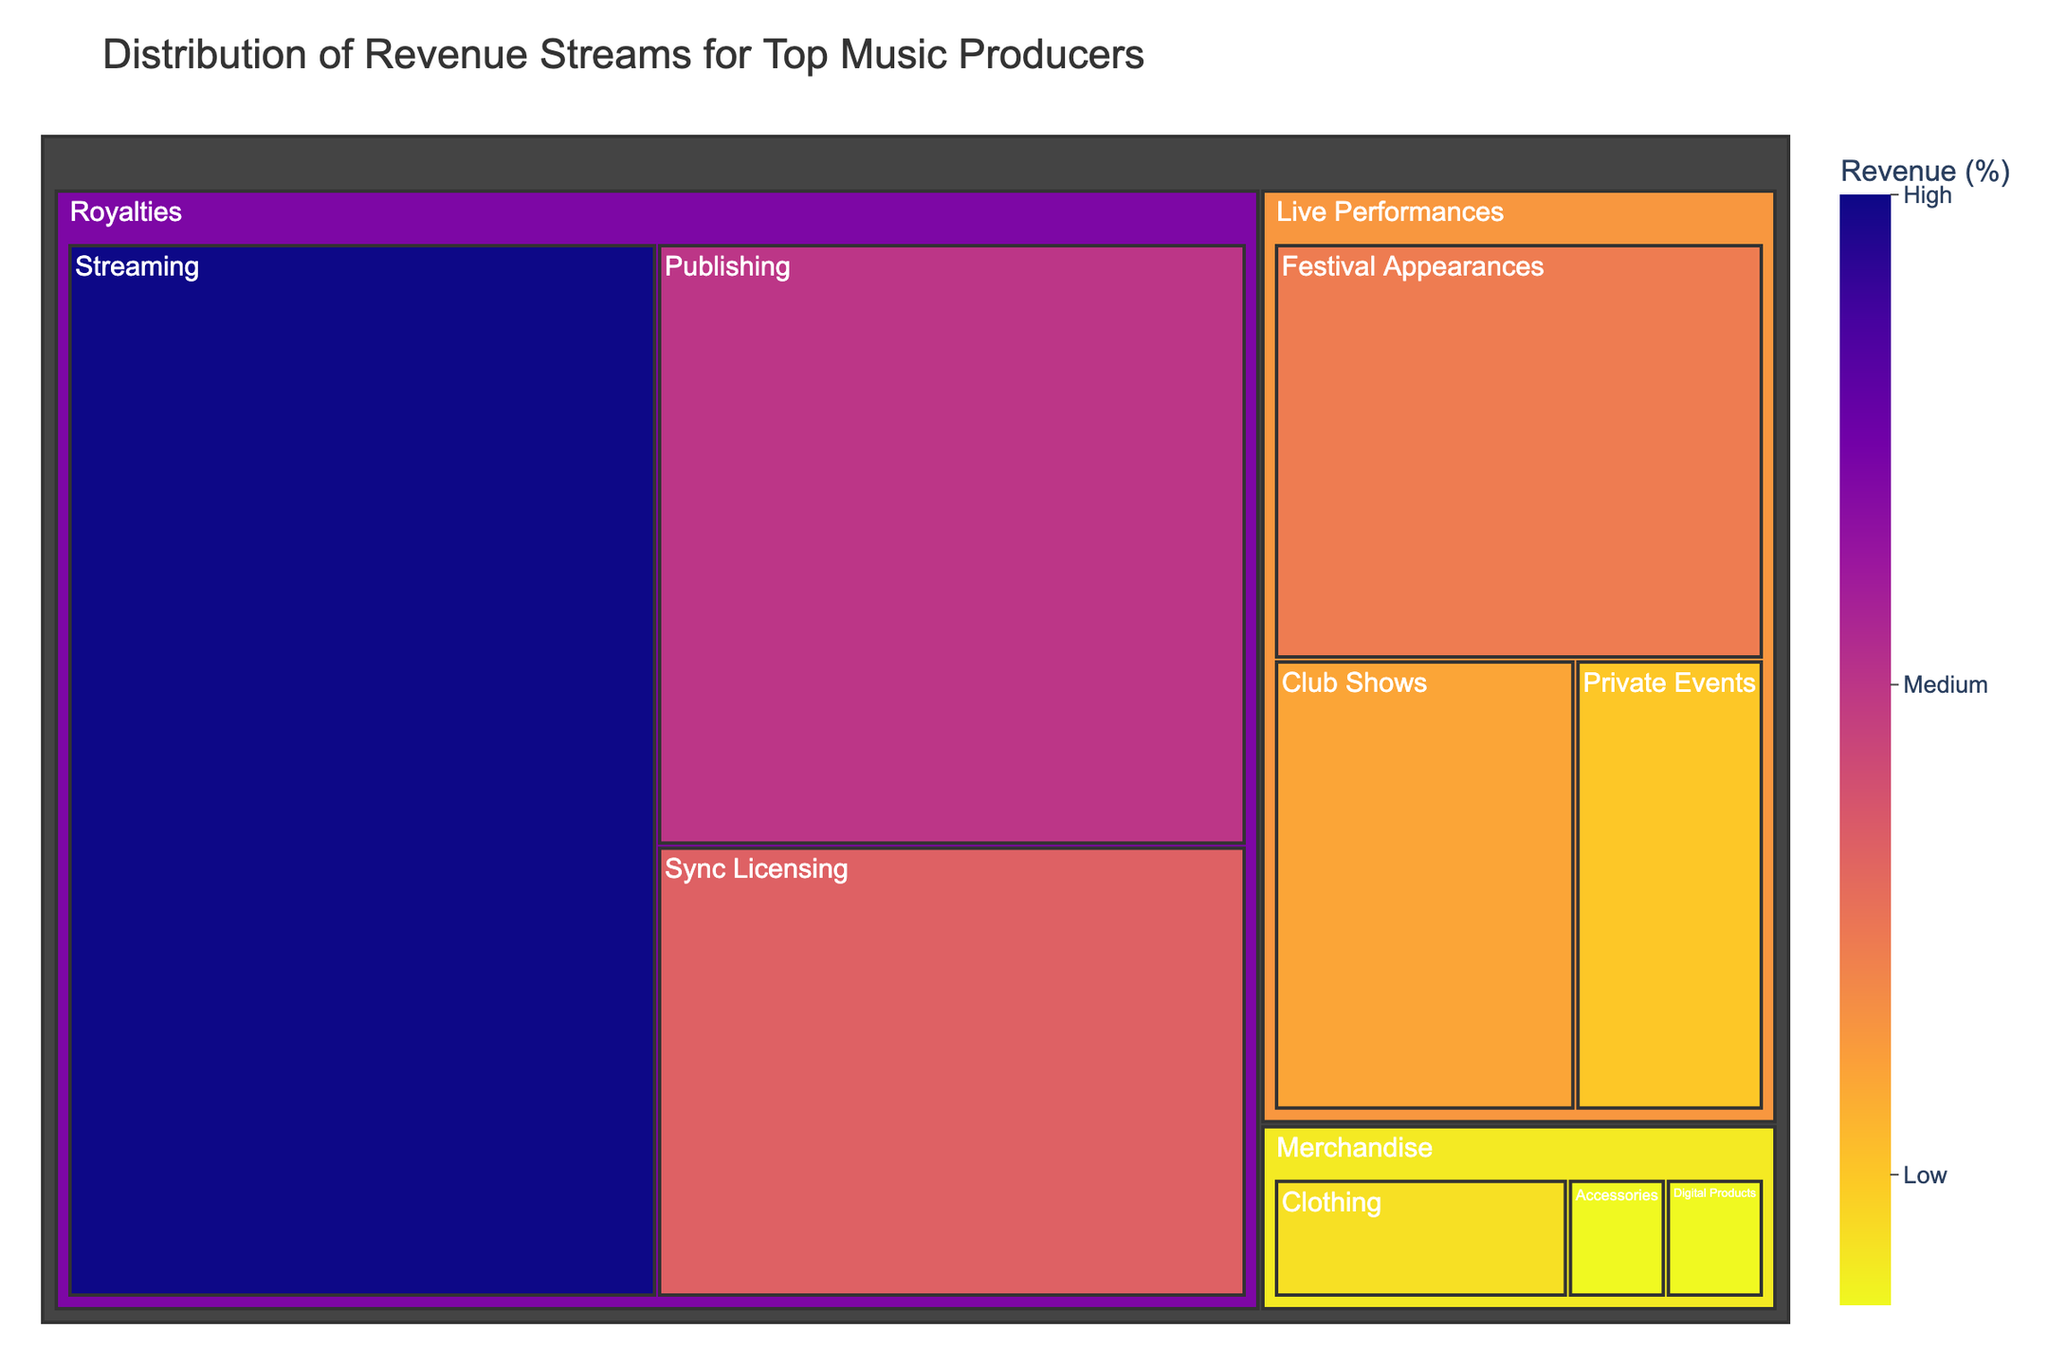what is the largest revenue stream category? The figure shows that the area with the largest size represents the largest revenue stream category. The "Royalties" section occupies the most space, indicating it is the largest revenue category.
Answer: Royalties which specific subcategory within royalties contributes the most to the revenue? Within the "Royalties" section, the "Streaming" subcategory occupies the largest area, indicating it contributes the most to revenue within this category.
Answer: Streaming how much revenue do live performances contribute in total? Summing up the values of subcategories under "Live Performances" (Festival Appearances, Club Shows, Private Events): 12 + 8 + 5 = 25.
Answer: 25 which revenue stream is the smallest in terms of contribution? The subcategory with the smallest area under all categories is "Accessories" and "Digital Products" under Merchandise, each with a value of 1.
Answer: Accessories, Digital Products compare the revenue from private events to club shows. which is higher? Comparing the areas for "Private Events" and "Club Shows" under "Live Performances," Club Shows has a higher value (8) than Private Events (5).
Answer: Club Shows how does merchandise revenue compare to royalties revenue in percentage terms? The total revenue from merchandise (3 + 1 + 1 = 5) compared to the total revenue from royalties (35 + 20 + 15 = 70) is 5 out of 100. Divide 5 by the total 100 and multiply by 100 to get the percentage: (5 / 100) * 100 = 5%.
Answer: 5% what is the combined revenue percentage of all royalties subcategories? Adding up the values for all subcategories under Royalties: 35 (Streaming) + 20 (Publishing) + 15 (Sync Licensing) = 70.
Answer: 70 list all categories contributing to the distribution of revenue streams. The categories visible in the figure are "Royalties," "Live Performances," and "Merchandise."
Answer: Royalties, Live Performances, Merchandise which subcategory under live performances contributes least to revenue? Among the subcategories under "Live Performances," "Private Events" has the smallest value of 5.
Answer: Private Events 